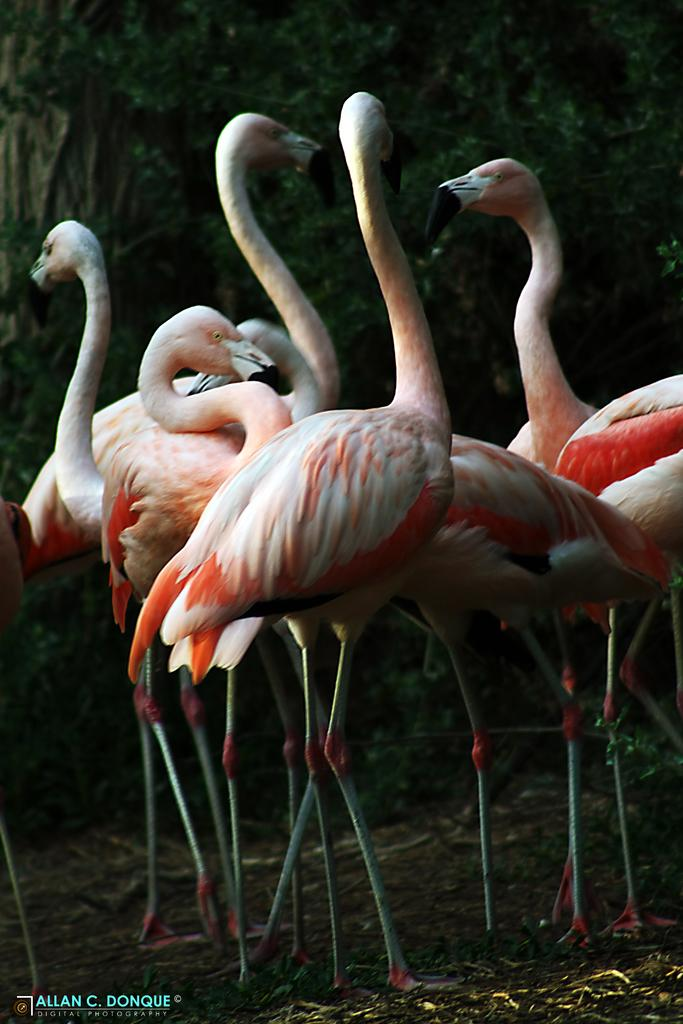What is located on the ground in the image? There is a group of birds on the ground in the image. What can be seen in the background of the image? There are trees in the background of the image. Is there any text present in the image? Yes, there is some text in the bottom left corner of the image. How many legs does the celery have in the image? There is no celery present in the image, so it is not possible to determine the number of legs it might have. 